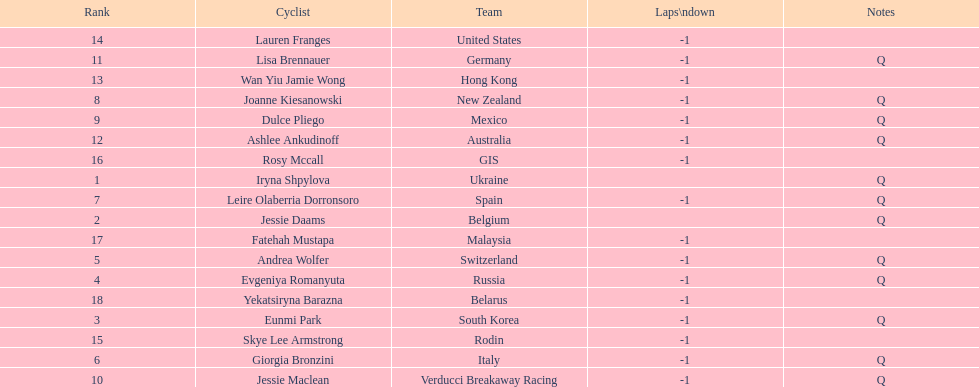Who was the top ranked competitor in this race? Iryna Shpylova. 